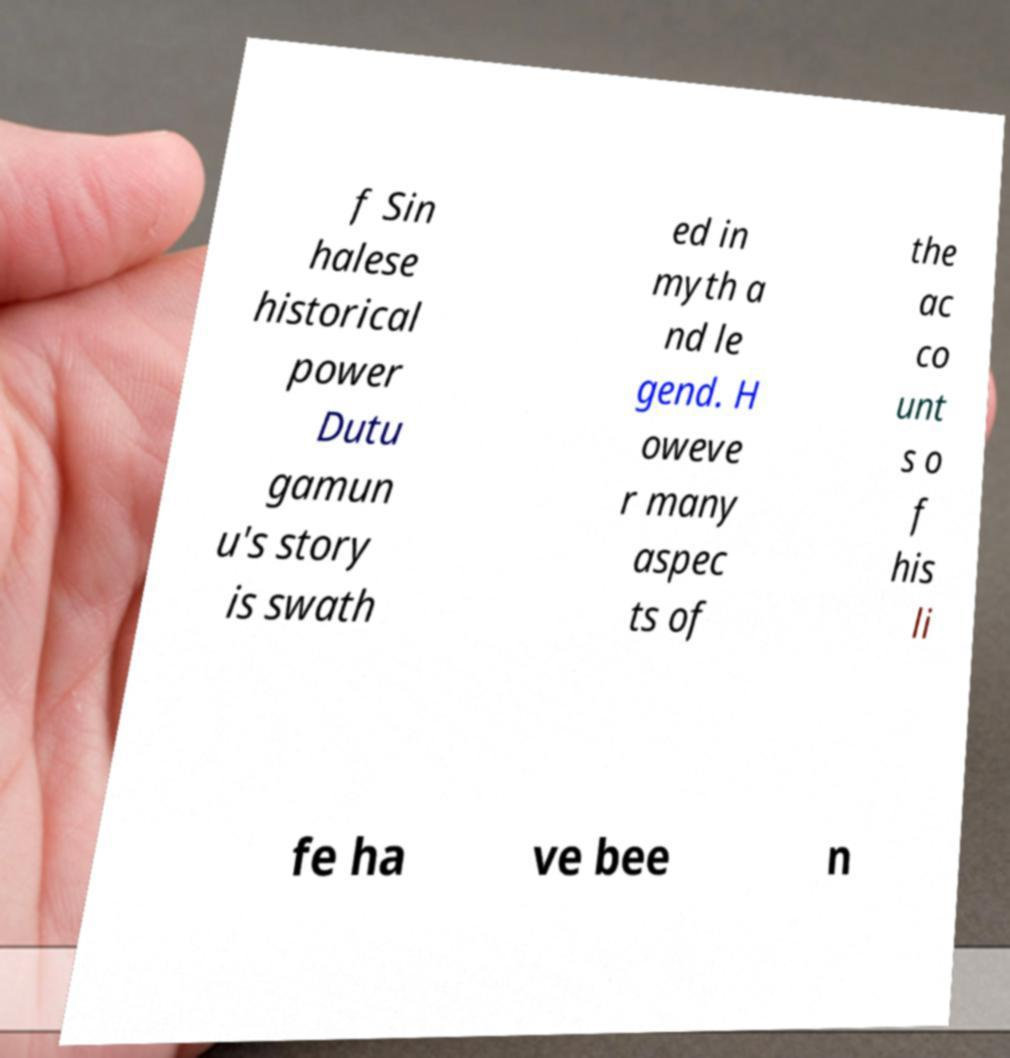I need the written content from this picture converted into text. Can you do that? f Sin halese historical power Dutu gamun u's story is swath ed in myth a nd le gend. H oweve r many aspec ts of the ac co unt s o f his li fe ha ve bee n 